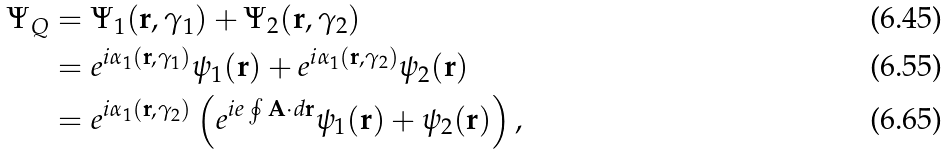Convert formula to latex. <formula><loc_0><loc_0><loc_500><loc_500>\Psi _ { Q } & = \Psi _ { 1 } ( \mathbf r , \gamma _ { 1 } ) + \Psi _ { 2 } ( \mathbf r , \gamma _ { 2 } ) \\ & = e ^ { i \alpha _ { 1 } ( \mathbf r , \gamma _ { 1 } ) } \psi _ { 1 } ( \mathbf r ) + e ^ { i \alpha _ { 1 } ( \mathbf r , \gamma _ { 2 } ) } \psi _ { 2 } ( \mathbf r ) \\ & = e ^ { i \alpha _ { 1 } ( \mathbf r , \gamma _ { 2 } ) } \left ( e ^ { i e \oint \mathbf A \cdot d \mathbf r } \psi _ { 1 } ( \mathbf r ) + \psi _ { 2 } ( \mathbf r ) \right ) ,</formula> 